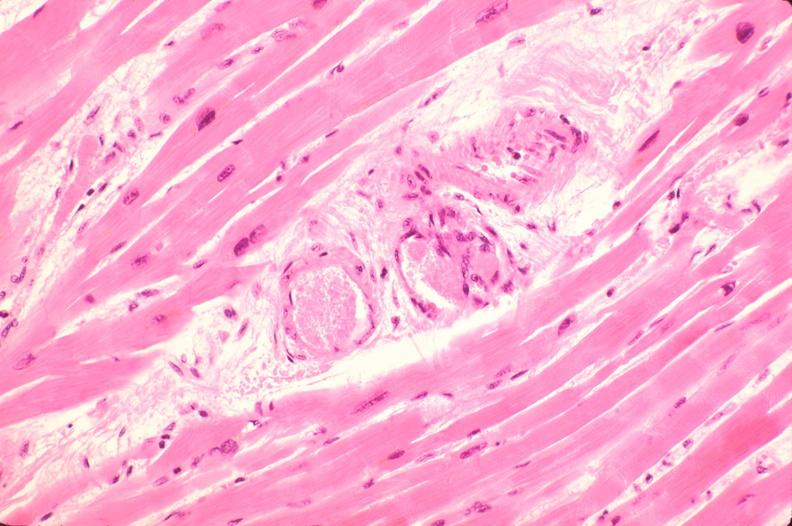what does this image show?
Answer the question using a single word or phrase. Heart 